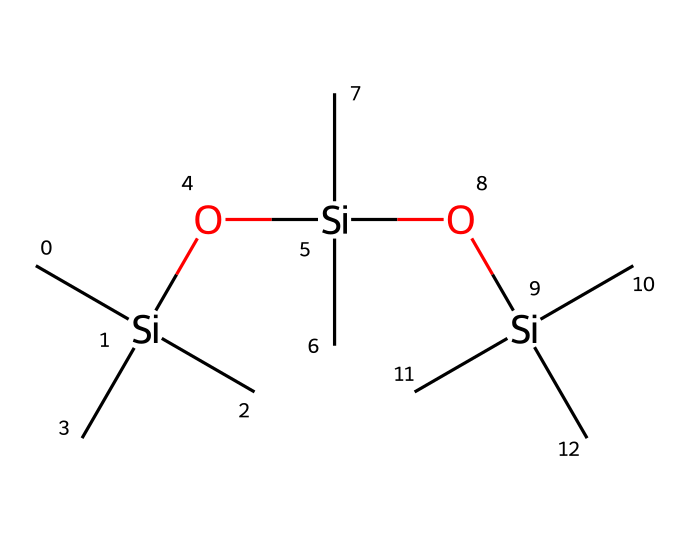what is the total number of silicon atoms in this compound? The SMILES representation shows three instances of the silicon atom, indicated by 'Si'. Each 'Si' corresponds to one silicon atom, and there are no additional silicon atoms depicted in the structure.
Answer: three how many carbon atoms are in this molecular structure? In the provided SMILES, there are multiple 'C' symbols, each representing a carbon atom. Counting them results in a total of nine carbon atoms present within the structure.
Answer: nine how many oxygen atoms are present in this molecule? The SMILES shows two occurrences of 'O', which indicates there are two oxygen atoms in the molecular structure.
Answer: two what type of polymer does this structure approximate? The structure suggests a type of polysiloxane polymer due to the repeating Si-O units within the arrangement.
Answer: polysiloxane what is the role of silicon in this chemical? Silicon in this organosilicon compound provides the framework that allows for flexibility and stability, particularly important in ink formulations.
Answer: framework how many branches does the central silicon atom have? The central silicon atom has three branches, each represented by the three 'C' in its vicinity. This indicates that it is connected with three carbon groups.
Answer: three what is a potential application of this organosilicon compound in ink formulation? The compound could serve as a binder, contributing to the durability and flexibility of the ink when used for transcribing classical texts.
Answer: binder 